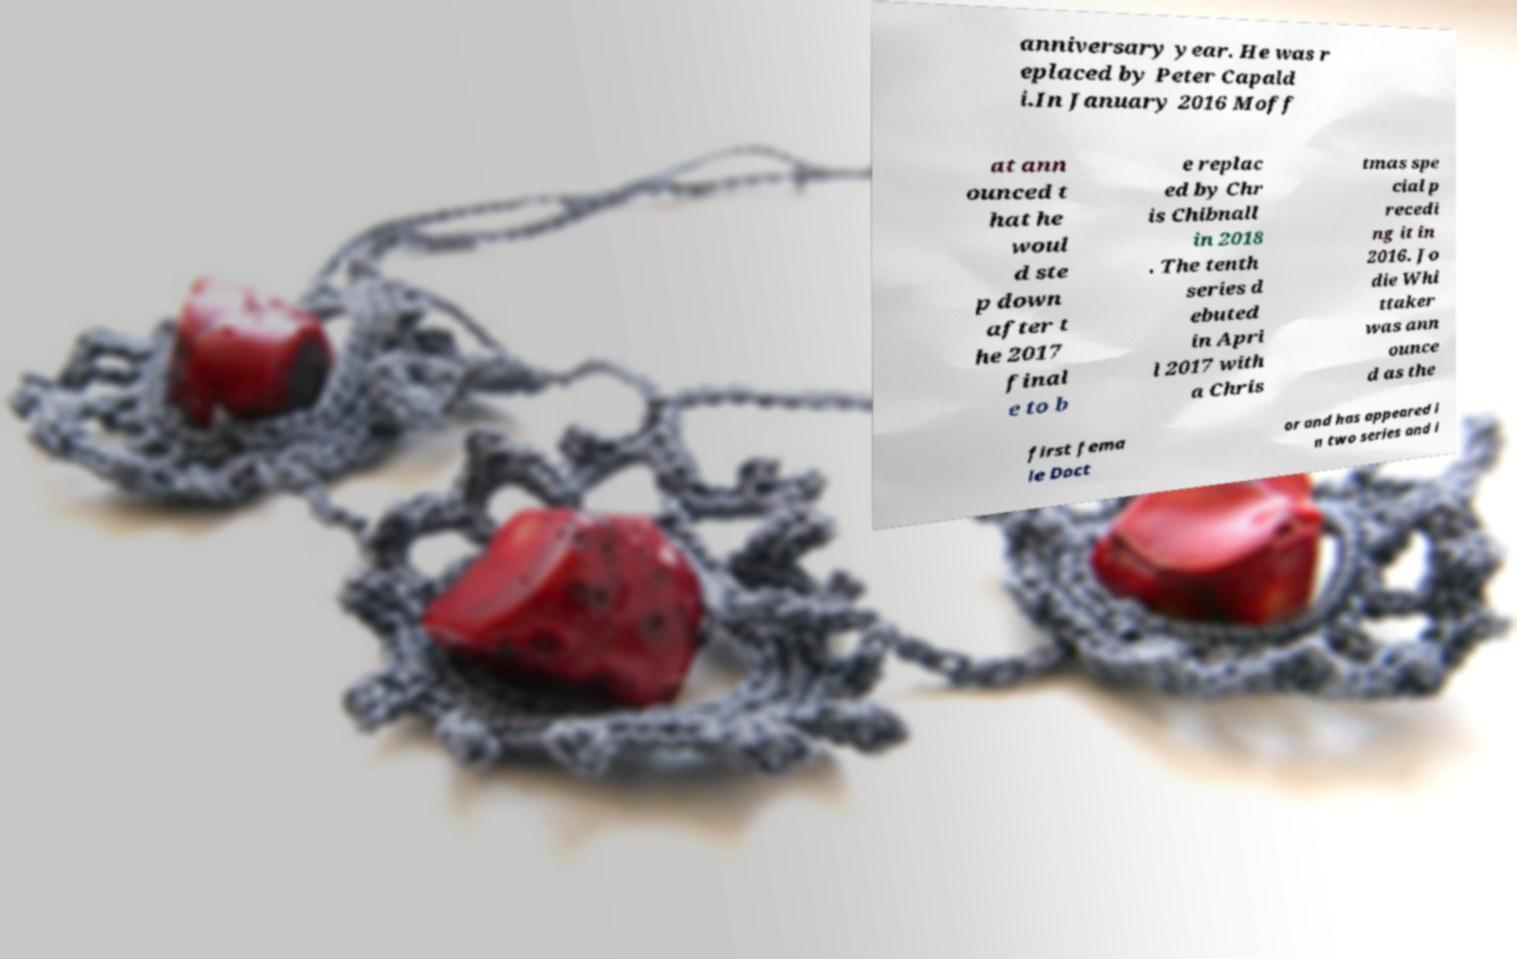Please identify and transcribe the text found in this image. anniversary year. He was r eplaced by Peter Capald i.In January 2016 Moff at ann ounced t hat he woul d ste p down after t he 2017 final e to b e replac ed by Chr is Chibnall in 2018 . The tenth series d ebuted in Apri l 2017 with a Chris tmas spe cial p recedi ng it in 2016. Jo die Whi ttaker was ann ounce d as the first fema le Doct or and has appeared i n two series and i 